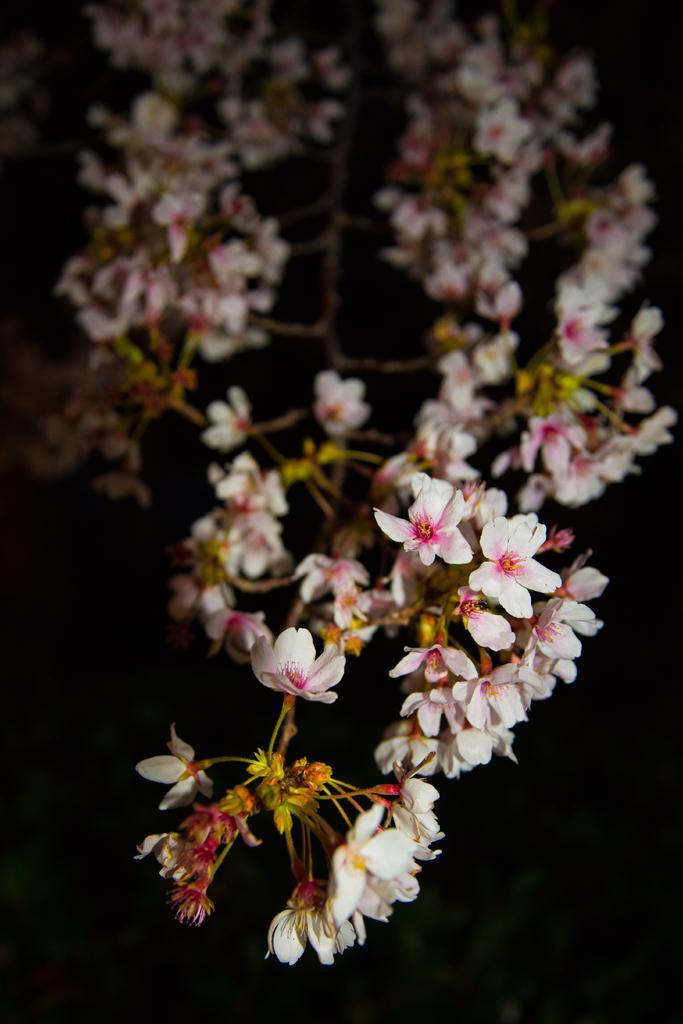Could you give a brief overview of what you see in this image? In this image, we can see a stem with flowers and buds. 